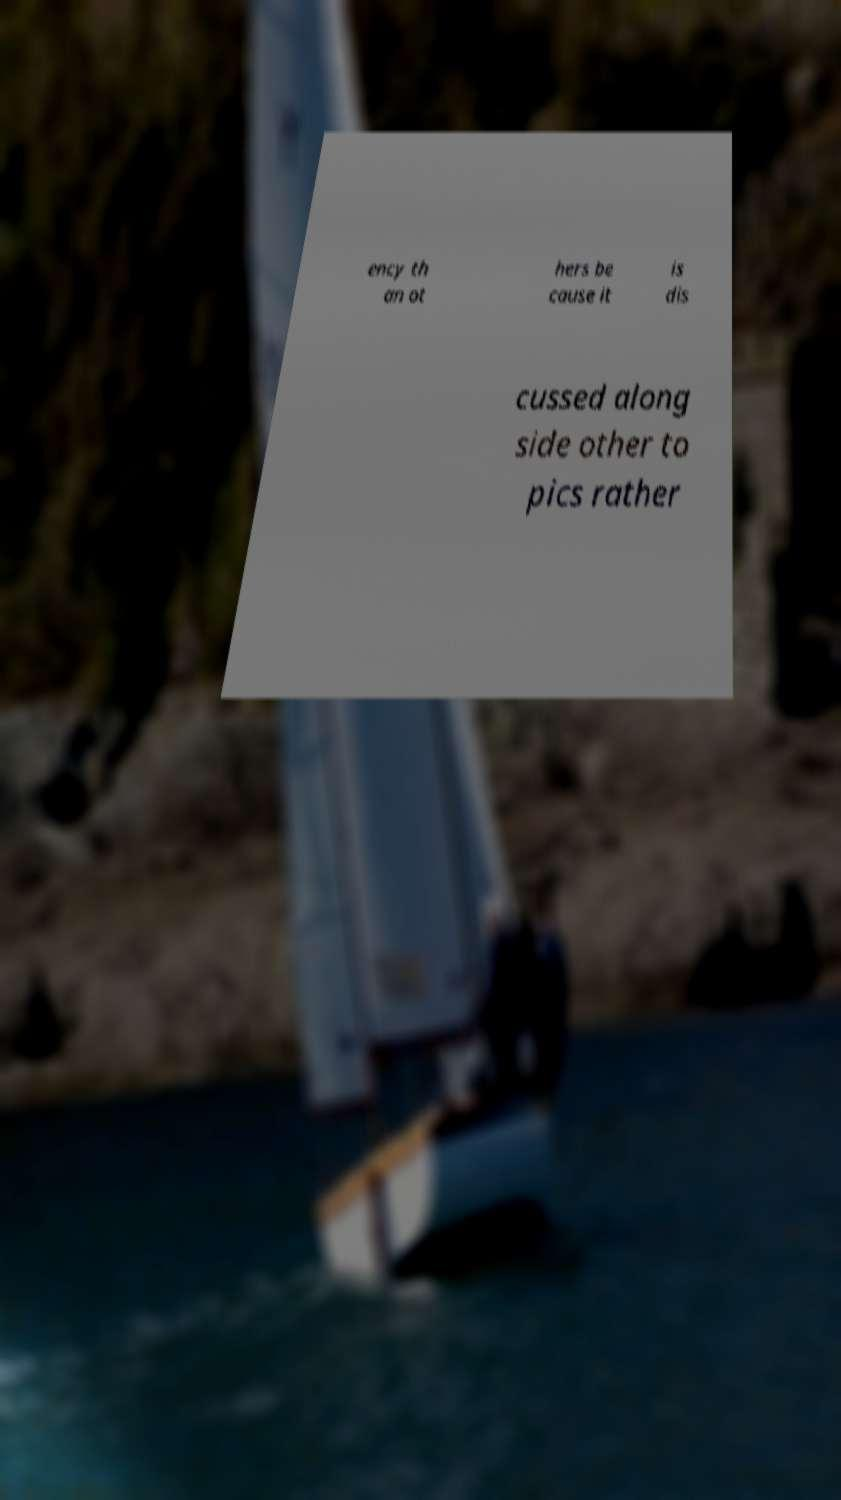I need the written content from this picture converted into text. Can you do that? ency th an ot hers be cause it is dis cussed along side other to pics rather 